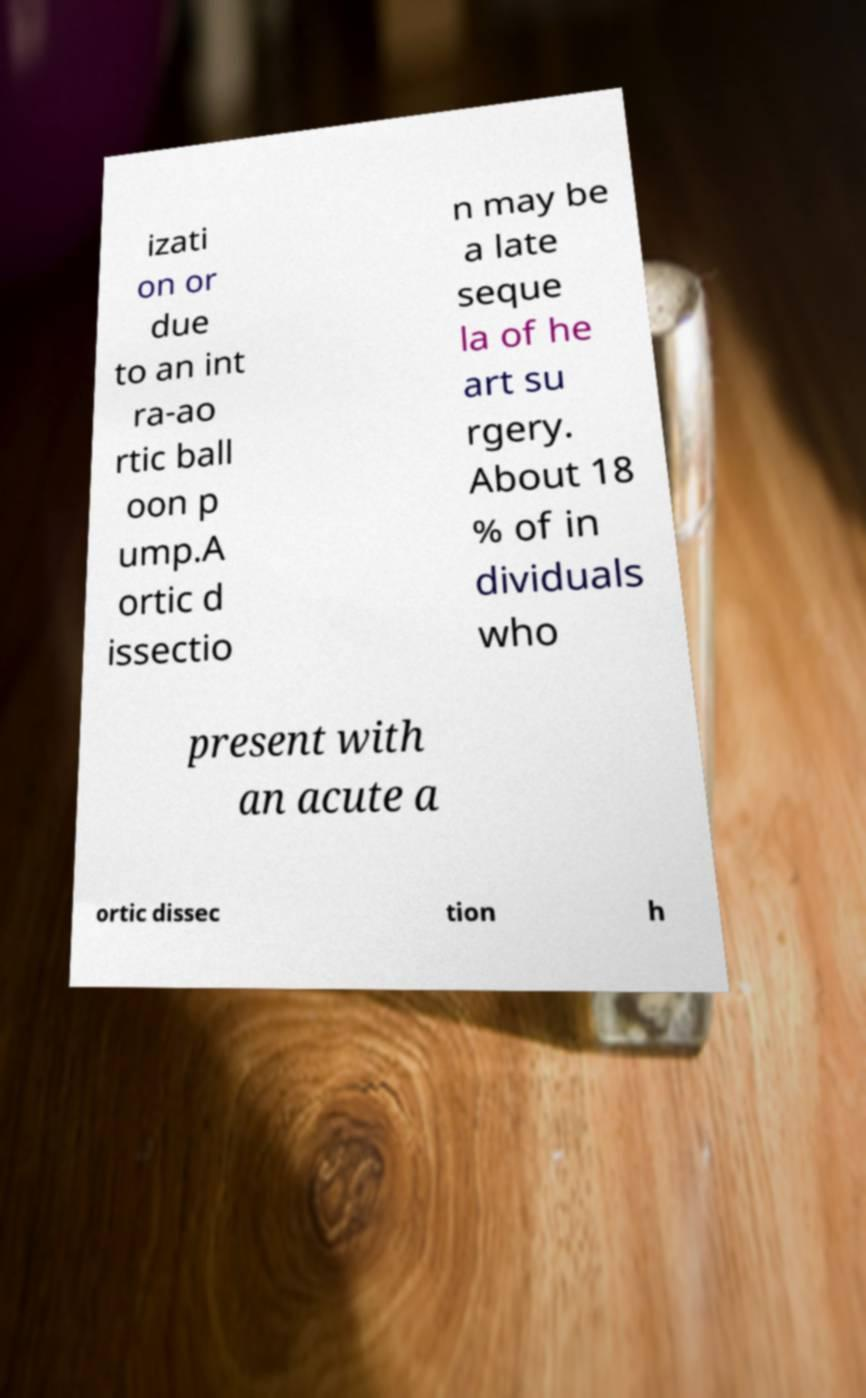Could you assist in decoding the text presented in this image and type it out clearly? izati on or due to an int ra-ao rtic ball oon p ump.A ortic d issectio n may be a late seque la of he art su rgery. About 18 % of in dividuals who present with an acute a ortic dissec tion h 